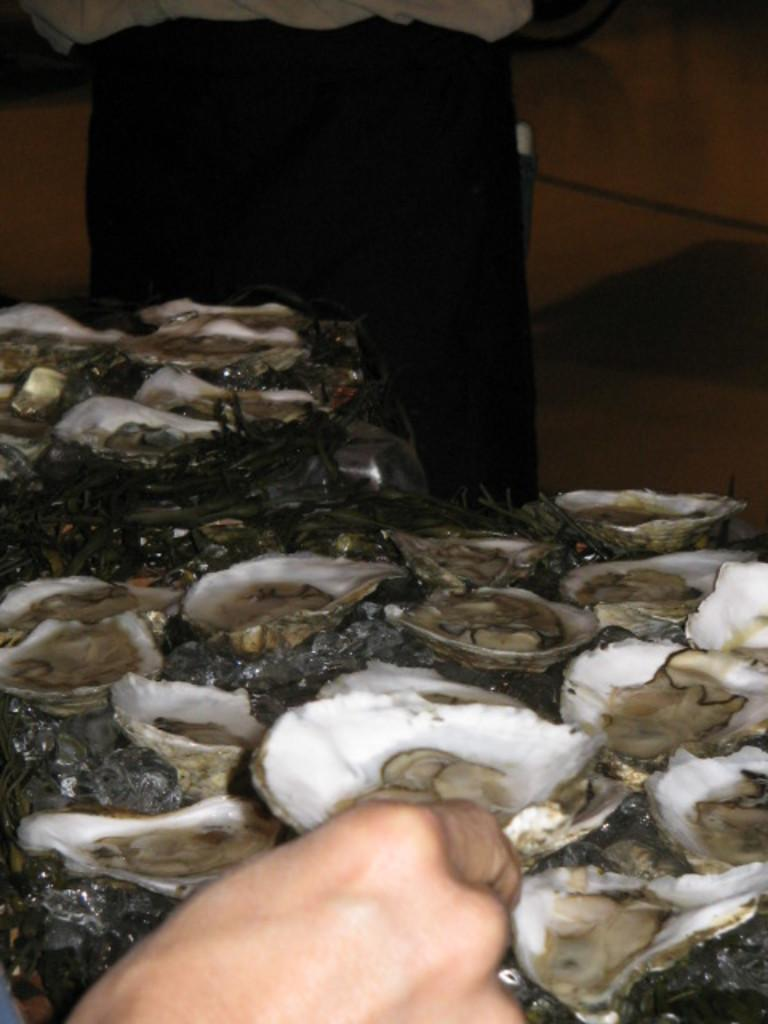What part of the human body can be seen at the bottom of the image? There is a human hand visible at the bottom of the image. What type of seafood is present in the image? There are oysters in the image. Can you describe the appearance of the oysters? The oysters have different colors, including white. What type of car is parked next to the oysters in the image? There is no car present in the image; it only features a human hand and oysters. 